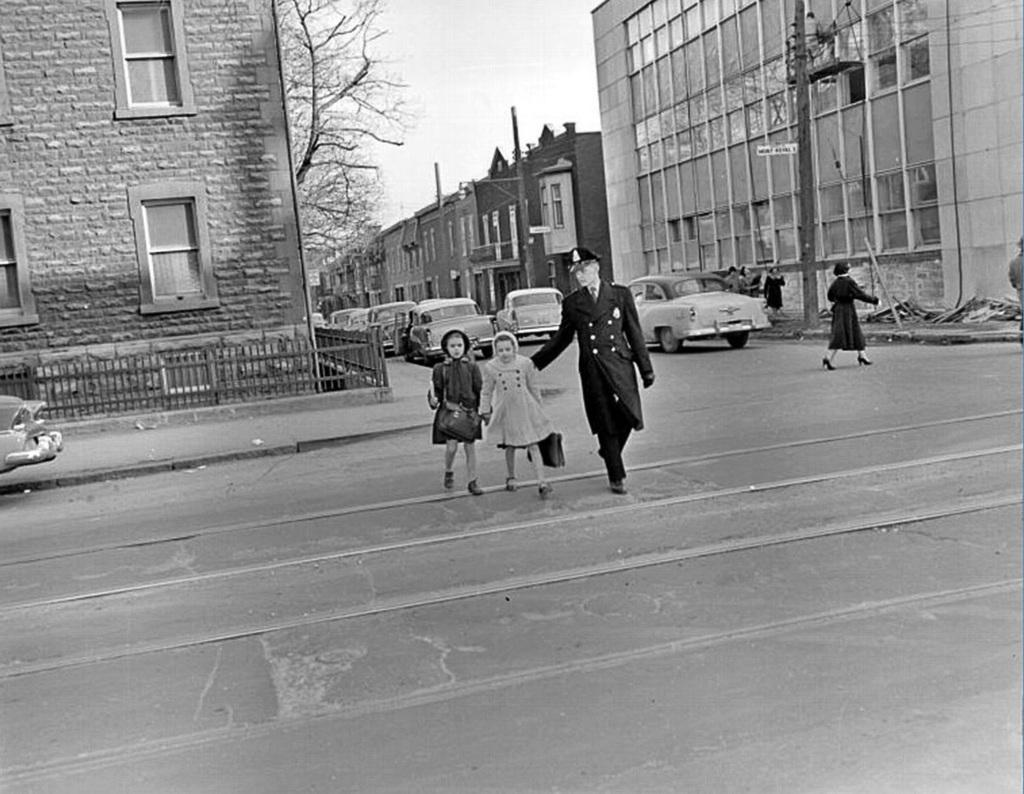What can be seen in the image in terms of human presence? There are people standing in the image. What else is present in the image besides people? There are vehicles and buildings in the image. Are there any specific features of the buildings mentioned in the image? Yes, there are windows in the image. What type of natural element is present in the image? There is a tree in the image. What is the color scheme of the image? The image is black and white in color. Is there any butter visible in the image? There is no butter present in the image. What type of event is taking place in the image? The image does not depict a specific event; it shows people, vehicles, buildings, windows, a tree, and has a black and white color scheme. 